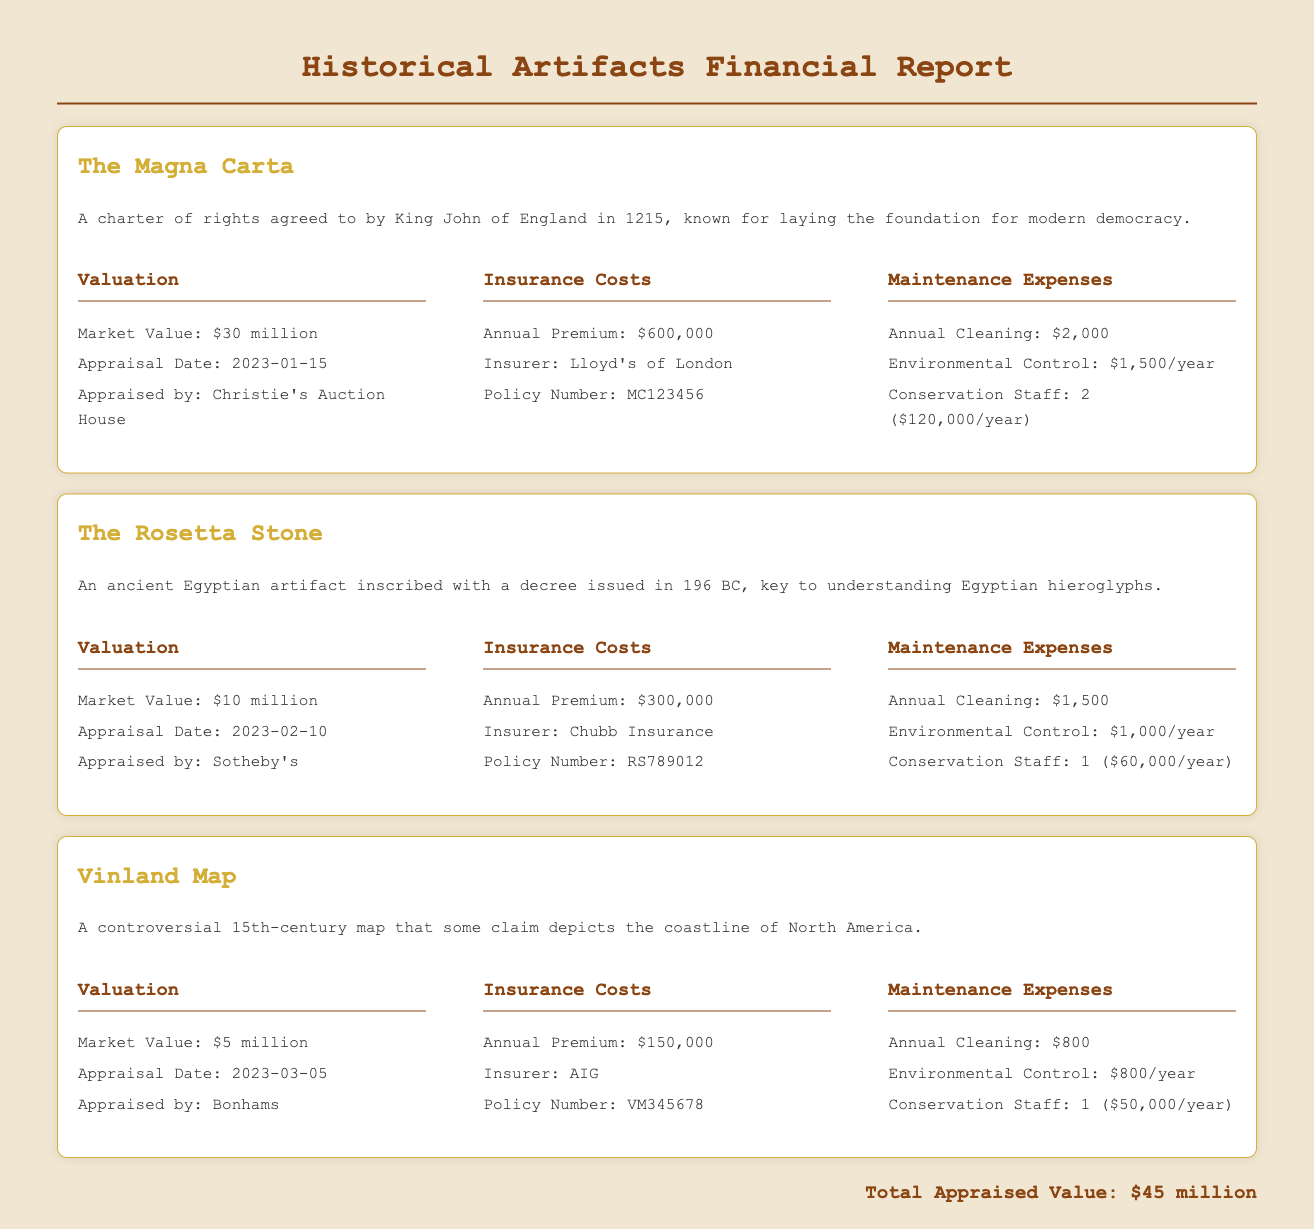What is the market value of The Magna Carta? The market value is explicitly stated in the document as $30 million.
Answer: $30 million Who appraised The Rosetta Stone? The document indicates that The Rosetta Stone was appraised by Sotheby's.
Answer: Sotheby's What is the annual premium for the insurance of the Vinland Map? The annual premium for Vinland Map's insurance is provided as $150,000.
Answer: $150,000 How much does The Magna Carta cost for annual conservation staff? The document reveals that the conservation staff for The Magna Carta costs $120,000 per year.
Answer: $120,000/year Which insurer is for The Rosetta Stone? The insurer for The Rosetta Stone, as listed in the document, is Chubb Insurance.
Answer: Chubb Insurance What is the total appraised value of all artifacts? The total appraised value, noted at the bottom of the document, is $45 million.
Answer: $45 million What is the environmental control cost for The Vinland Map? The document shows that the environmental control cost for The Vinland Map is $800 per year.
Answer: $800/year What year was The Magna Carta appraised? The appraisal date for The Magna Carta is mentioned as January 15, 2023.
Answer: 2023-01-15 How many conservation staff members are assigned to The Rosetta Stone? According to the information, The Rosetta Stone has 1 conservation staff member.
Answer: 1 